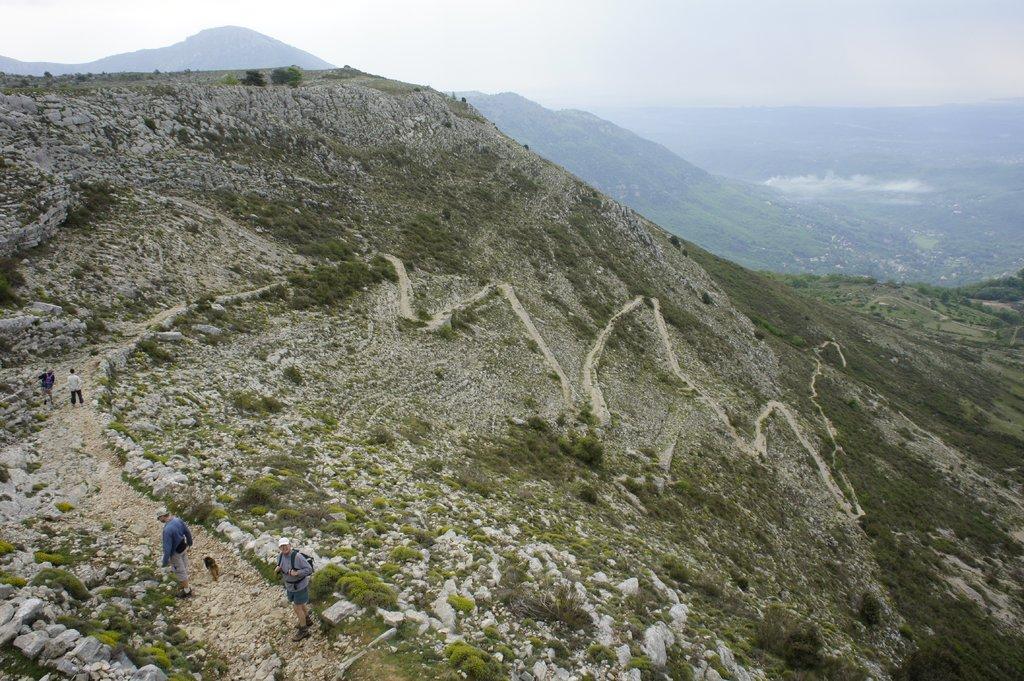How would you summarize this image in a sentence or two? In this image, we can see hills and there are some people. At the top, there is sky. 